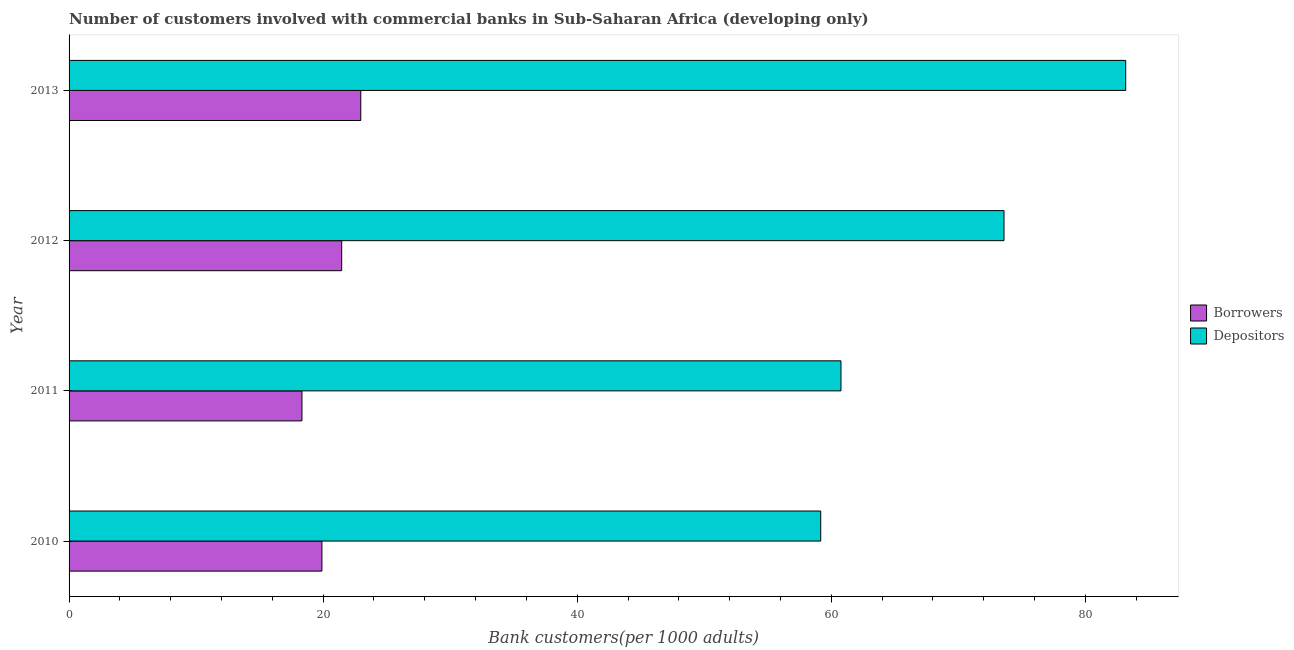How many different coloured bars are there?
Give a very brief answer. 2. What is the label of the 2nd group of bars from the top?
Keep it short and to the point. 2012. In how many cases, is the number of bars for a given year not equal to the number of legend labels?
Ensure brevity in your answer.  0. What is the number of borrowers in 2011?
Make the answer very short. 18.33. Across all years, what is the maximum number of borrowers?
Offer a very short reply. 22.96. Across all years, what is the minimum number of depositors?
Keep it short and to the point. 59.17. In which year was the number of depositors minimum?
Offer a terse response. 2010. What is the total number of borrowers in the graph?
Give a very brief answer. 82.66. What is the difference between the number of depositors in 2011 and that in 2012?
Give a very brief answer. -12.83. What is the difference between the number of depositors in 2011 and the number of borrowers in 2013?
Your answer should be compact. 37.8. What is the average number of depositors per year?
Provide a succinct answer. 69.18. In the year 2011, what is the difference between the number of borrowers and number of depositors?
Offer a very short reply. -42.43. In how many years, is the number of borrowers greater than 8 ?
Offer a terse response. 4. What is the ratio of the number of borrowers in 2011 to that in 2013?
Offer a terse response. 0.8. Is the difference between the number of depositors in 2010 and 2011 greater than the difference between the number of borrowers in 2010 and 2011?
Your answer should be compact. No. What is the difference between the highest and the second highest number of depositors?
Ensure brevity in your answer.  9.58. What is the difference between the highest and the lowest number of depositors?
Your answer should be compact. 24.01. In how many years, is the number of borrowers greater than the average number of borrowers taken over all years?
Provide a short and direct response. 2. Is the sum of the number of depositors in 2010 and 2013 greater than the maximum number of borrowers across all years?
Give a very brief answer. Yes. What does the 2nd bar from the top in 2010 represents?
Make the answer very short. Borrowers. What does the 2nd bar from the bottom in 2012 represents?
Give a very brief answer. Depositors. How many years are there in the graph?
Provide a short and direct response. 4. What is the difference between two consecutive major ticks on the X-axis?
Offer a very short reply. 20. Does the graph contain any zero values?
Your answer should be very brief. No. Does the graph contain grids?
Your response must be concise. No. Where does the legend appear in the graph?
Your answer should be compact. Center right. What is the title of the graph?
Your answer should be very brief. Number of customers involved with commercial banks in Sub-Saharan Africa (developing only). What is the label or title of the X-axis?
Provide a succinct answer. Bank customers(per 1000 adults). What is the label or title of the Y-axis?
Ensure brevity in your answer.  Year. What is the Bank customers(per 1000 adults) in Borrowers in 2010?
Give a very brief answer. 19.9. What is the Bank customers(per 1000 adults) in Depositors in 2010?
Offer a terse response. 59.17. What is the Bank customers(per 1000 adults) in Borrowers in 2011?
Provide a short and direct response. 18.33. What is the Bank customers(per 1000 adults) of Depositors in 2011?
Keep it short and to the point. 60.76. What is the Bank customers(per 1000 adults) in Borrowers in 2012?
Your response must be concise. 21.46. What is the Bank customers(per 1000 adults) of Depositors in 2012?
Make the answer very short. 73.6. What is the Bank customers(per 1000 adults) of Borrowers in 2013?
Offer a terse response. 22.96. What is the Bank customers(per 1000 adults) in Depositors in 2013?
Your response must be concise. 83.18. Across all years, what is the maximum Bank customers(per 1000 adults) in Borrowers?
Your response must be concise. 22.96. Across all years, what is the maximum Bank customers(per 1000 adults) in Depositors?
Provide a succinct answer. 83.18. Across all years, what is the minimum Bank customers(per 1000 adults) of Borrowers?
Your response must be concise. 18.33. Across all years, what is the minimum Bank customers(per 1000 adults) of Depositors?
Make the answer very short. 59.17. What is the total Bank customers(per 1000 adults) of Borrowers in the graph?
Ensure brevity in your answer.  82.66. What is the total Bank customers(per 1000 adults) in Depositors in the graph?
Your answer should be compact. 276.7. What is the difference between the Bank customers(per 1000 adults) of Borrowers in 2010 and that in 2011?
Offer a terse response. 1.57. What is the difference between the Bank customers(per 1000 adults) of Depositors in 2010 and that in 2011?
Provide a short and direct response. -1.59. What is the difference between the Bank customers(per 1000 adults) of Borrowers in 2010 and that in 2012?
Offer a very short reply. -1.56. What is the difference between the Bank customers(per 1000 adults) of Depositors in 2010 and that in 2012?
Keep it short and to the point. -14.43. What is the difference between the Bank customers(per 1000 adults) of Borrowers in 2010 and that in 2013?
Your answer should be very brief. -3.06. What is the difference between the Bank customers(per 1000 adults) in Depositors in 2010 and that in 2013?
Provide a succinct answer. -24.01. What is the difference between the Bank customers(per 1000 adults) of Borrowers in 2011 and that in 2012?
Keep it short and to the point. -3.13. What is the difference between the Bank customers(per 1000 adults) in Depositors in 2011 and that in 2012?
Provide a short and direct response. -12.83. What is the difference between the Bank customers(per 1000 adults) of Borrowers in 2011 and that in 2013?
Your response must be concise. -4.63. What is the difference between the Bank customers(per 1000 adults) of Depositors in 2011 and that in 2013?
Give a very brief answer. -22.41. What is the difference between the Bank customers(per 1000 adults) in Borrowers in 2012 and that in 2013?
Offer a terse response. -1.5. What is the difference between the Bank customers(per 1000 adults) in Depositors in 2012 and that in 2013?
Your response must be concise. -9.58. What is the difference between the Bank customers(per 1000 adults) in Borrowers in 2010 and the Bank customers(per 1000 adults) in Depositors in 2011?
Give a very brief answer. -40.86. What is the difference between the Bank customers(per 1000 adults) in Borrowers in 2010 and the Bank customers(per 1000 adults) in Depositors in 2012?
Your answer should be compact. -53.69. What is the difference between the Bank customers(per 1000 adults) of Borrowers in 2010 and the Bank customers(per 1000 adults) of Depositors in 2013?
Keep it short and to the point. -63.27. What is the difference between the Bank customers(per 1000 adults) in Borrowers in 2011 and the Bank customers(per 1000 adults) in Depositors in 2012?
Your answer should be very brief. -55.26. What is the difference between the Bank customers(per 1000 adults) in Borrowers in 2011 and the Bank customers(per 1000 adults) in Depositors in 2013?
Your answer should be very brief. -64.84. What is the difference between the Bank customers(per 1000 adults) of Borrowers in 2012 and the Bank customers(per 1000 adults) of Depositors in 2013?
Provide a short and direct response. -61.72. What is the average Bank customers(per 1000 adults) in Borrowers per year?
Offer a terse response. 20.66. What is the average Bank customers(per 1000 adults) in Depositors per year?
Offer a very short reply. 69.18. In the year 2010, what is the difference between the Bank customers(per 1000 adults) of Borrowers and Bank customers(per 1000 adults) of Depositors?
Ensure brevity in your answer.  -39.26. In the year 2011, what is the difference between the Bank customers(per 1000 adults) of Borrowers and Bank customers(per 1000 adults) of Depositors?
Your answer should be very brief. -42.43. In the year 2012, what is the difference between the Bank customers(per 1000 adults) in Borrowers and Bank customers(per 1000 adults) in Depositors?
Make the answer very short. -52.14. In the year 2013, what is the difference between the Bank customers(per 1000 adults) of Borrowers and Bank customers(per 1000 adults) of Depositors?
Make the answer very short. -60.21. What is the ratio of the Bank customers(per 1000 adults) in Borrowers in 2010 to that in 2011?
Make the answer very short. 1.09. What is the ratio of the Bank customers(per 1000 adults) of Depositors in 2010 to that in 2011?
Your answer should be very brief. 0.97. What is the ratio of the Bank customers(per 1000 adults) in Borrowers in 2010 to that in 2012?
Ensure brevity in your answer.  0.93. What is the ratio of the Bank customers(per 1000 adults) of Depositors in 2010 to that in 2012?
Offer a very short reply. 0.8. What is the ratio of the Bank customers(per 1000 adults) of Borrowers in 2010 to that in 2013?
Keep it short and to the point. 0.87. What is the ratio of the Bank customers(per 1000 adults) in Depositors in 2010 to that in 2013?
Give a very brief answer. 0.71. What is the ratio of the Bank customers(per 1000 adults) in Borrowers in 2011 to that in 2012?
Give a very brief answer. 0.85. What is the ratio of the Bank customers(per 1000 adults) of Depositors in 2011 to that in 2012?
Give a very brief answer. 0.83. What is the ratio of the Bank customers(per 1000 adults) of Borrowers in 2011 to that in 2013?
Provide a succinct answer. 0.8. What is the ratio of the Bank customers(per 1000 adults) in Depositors in 2011 to that in 2013?
Make the answer very short. 0.73. What is the ratio of the Bank customers(per 1000 adults) of Borrowers in 2012 to that in 2013?
Offer a terse response. 0.93. What is the ratio of the Bank customers(per 1000 adults) of Depositors in 2012 to that in 2013?
Your response must be concise. 0.88. What is the difference between the highest and the second highest Bank customers(per 1000 adults) of Borrowers?
Your answer should be very brief. 1.5. What is the difference between the highest and the second highest Bank customers(per 1000 adults) of Depositors?
Give a very brief answer. 9.58. What is the difference between the highest and the lowest Bank customers(per 1000 adults) in Borrowers?
Ensure brevity in your answer.  4.63. What is the difference between the highest and the lowest Bank customers(per 1000 adults) in Depositors?
Your response must be concise. 24.01. 